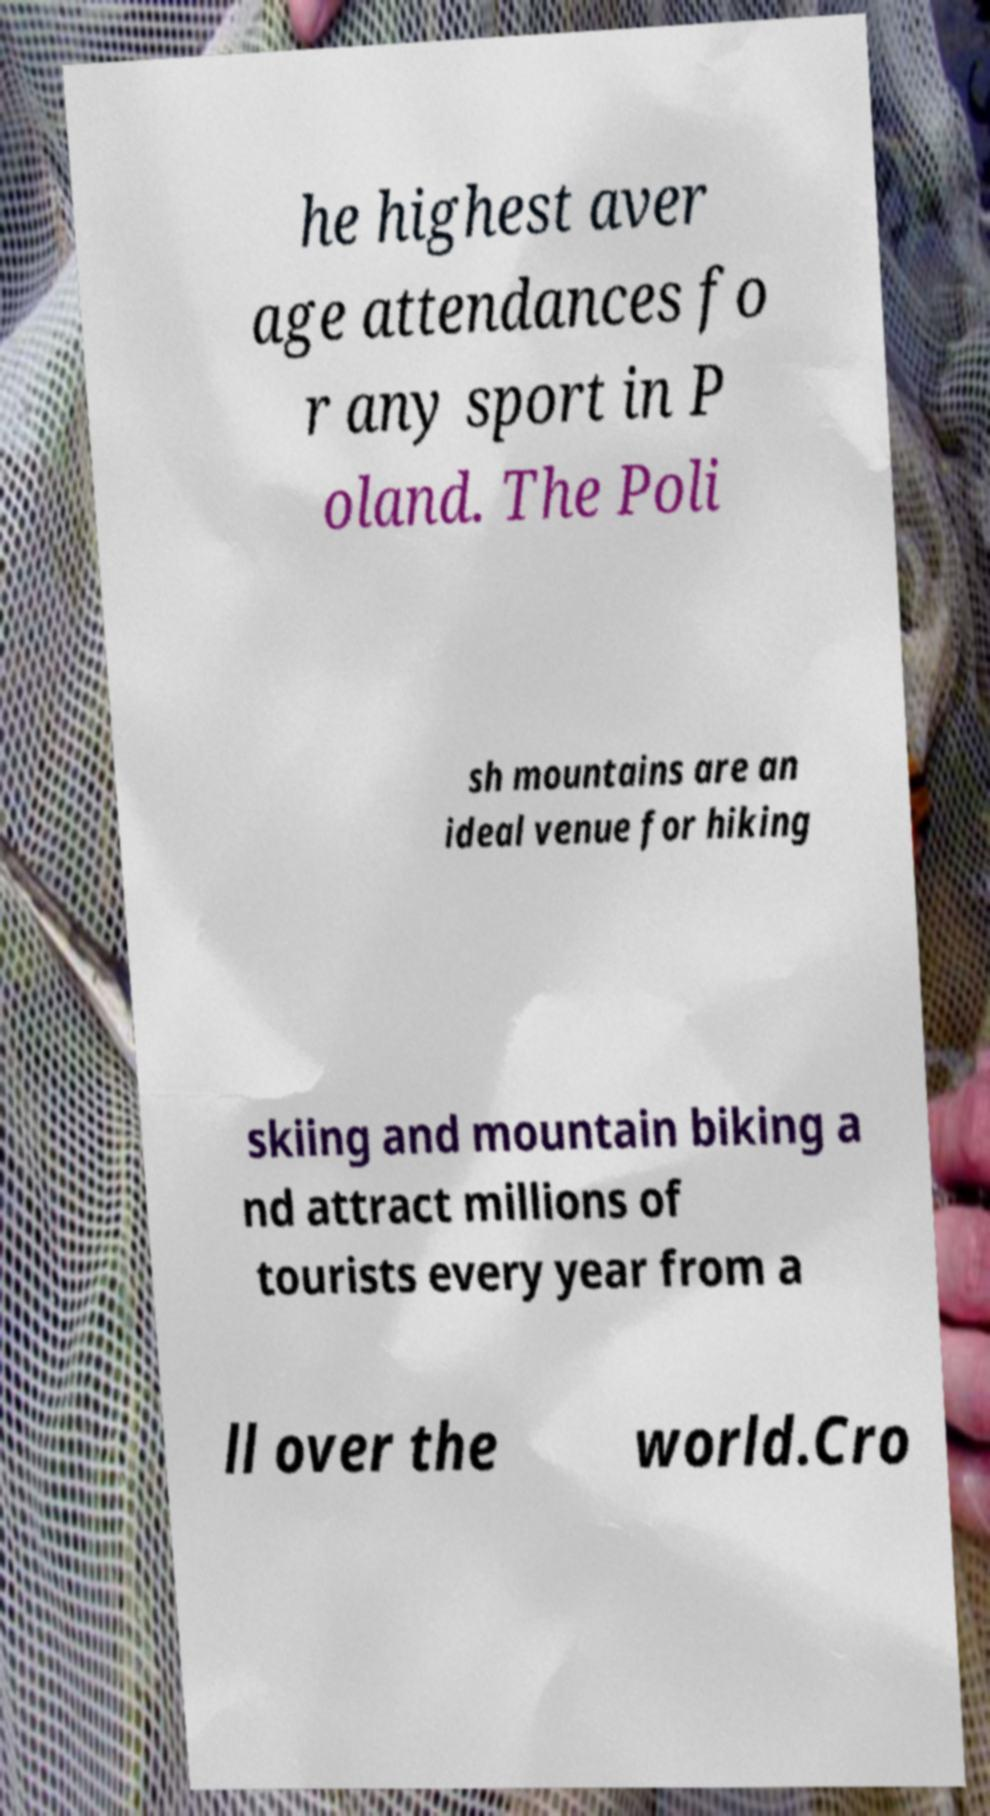Could you assist in decoding the text presented in this image and type it out clearly? he highest aver age attendances fo r any sport in P oland. The Poli sh mountains are an ideal venue for hiking skiing and mountain biking a nd attract millions of tourists every year from a ll over the world.Cro 